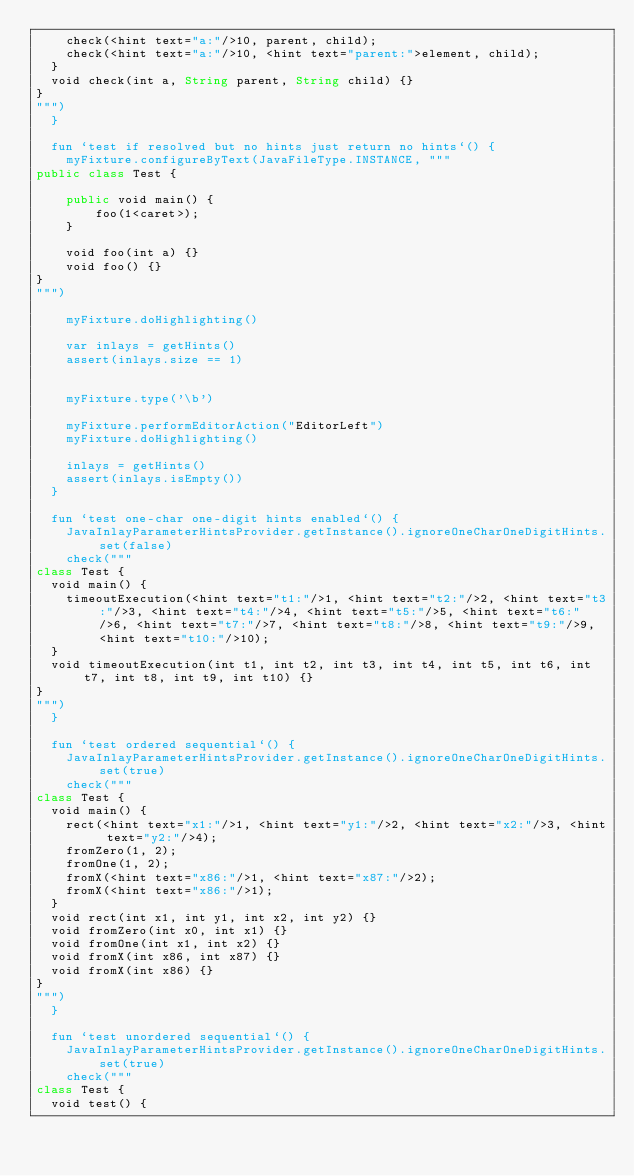<code> <loc_0><loc_0><loc_500><loc_500><_Kotlin_>    check(<hint text="a:"/>10, parent, child);
    check(<hint text="a:"/>10, <hint text="parent:">element, child);
  }
  void check(int a, String parent, String child) {}
}
""")
  }

  fun `test if resolved but no hints just return no hints`() {
    myFixture.configureByText(JavaFileType.INSTANCE, """
public class Test {

    public void main() {
        foo(1<caret>);
    }

    void foo(int a) {}
    void foo() {}
}
""")

    myFixture.doHighlighting()

    var inlays = getHints()
    assert(inlays.size == 1)


    myFixture.type('\b')

    myFixture.performEditorAction("EditorLeft")
    myFixture.doHighlighting()

    inlays = getHints()
    assert(inlays.isEmpty())
  }

  fun `test one-char one-digit hints enabled`() {
    JavaInlayParameterHintsProvider.getInstance().ignoreOneCharOneDigitHints.set(false)
    check("""
class Test {
  void main() {
    timeoutExecution(<hint text="t1:"/>1, <hint text="t2:"/>2, <hint text="t3:"/>3, <hint text="t4:"/>4, <hint text="t5:"/>5, <hint text="t6:"/>6, <hint text="t7:"/>7, <hint text="t8:"/>8, <hint text="t9:"/>9, <hint text="t10:"/>10);
  }
  void timeoutExecution(int t1, int t2, int t3, int t4, int t5, int t6, int t7, int t8, int t9, int t10) {}
}
""")
  }

  fun `test ordered sequential`() {
    JavaInlayParameterHintsProvider.getInstance().ignoreOneCharOneDigitHints.set(true)
    check("""
class Test {
  void main() {
    rect(<hint text="x1:"/>1, <hint text="y1:"/>2, <hint text="x2:"/>3, <hint text="y2:"/>4);
    fromZero(1, 2);
    fromOne(1, 2);
    fromX(<hint text="x86:"/>1, <hint text="x87:"/>2);
    fromX(<hint text="x86:"/>1);
  }
  void rect(int x1, int y1, int x2, int y2) {}
  void fromZero(int x0, int x1) {}
  void fromOne(int x1, int x2) {}
  void fromX(int x86, int x87) {}
  void fromX(int x86) {}
}
""")
  }

  fun `test unordered sequential`() {
    JavaInlayParameterHintsProvider.getInstance().ignoreOneCharOneDigitHints.set(true)
    check("""
class Test {
  void test() {</code> 